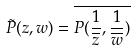Convert formula to latex. <formula><loc_0><loc_0><loc_500><loc_500>\tilde { P } ( z , w ) = \overline { P ( \frac { 1 } { \overline { z } } , \frac { 1 } { \overline { w } } ) }</formula> 